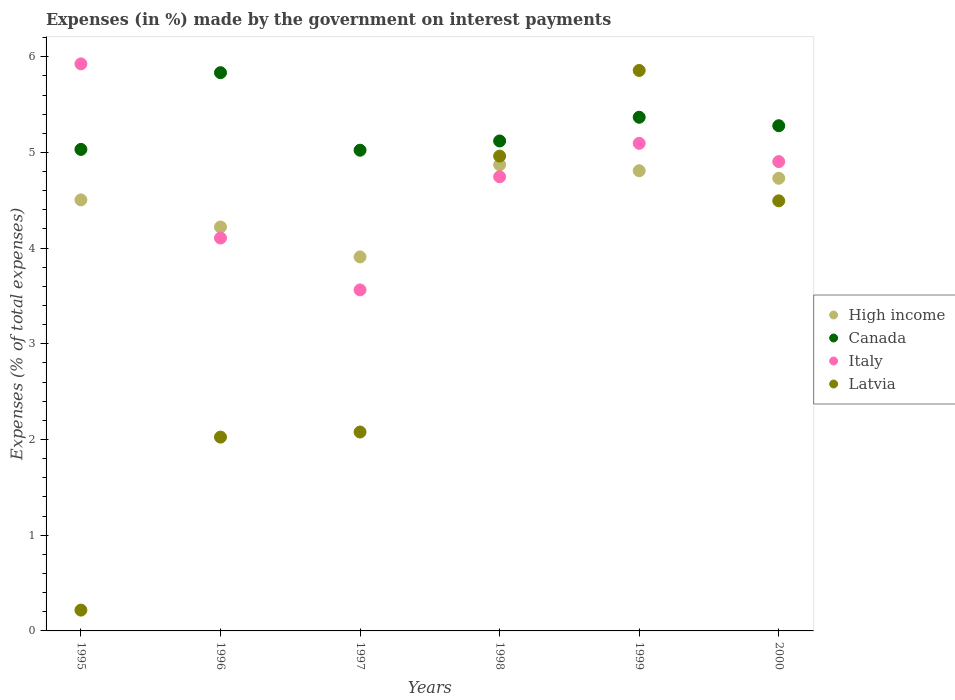What is the percentage of expenses made by the government on interest payments in Italy in 2000?
Your response must be concise. 4.9. Across all years, what is the maximum percentage of expenses made by the government on interest payments in Italy?
Your answer should be compact. 5.93. Across all years, what is the minimum percentage of expenses made by the government on interest payments in Latvia?
Give a very brief answer. 0.22. In which year was the percentage of expenses made by the government on interest payments in High income minimum?
Ensure brevity in your answer.  1997. What is the total percentage of expenses made by the government on interest payments in High income in the graph?
Offer a very short reply. 27.04. What is the difference between the percentage of expenses made by the government on interest payments in High income in 1995 and that in 1999?
Your response must be concise. -0.3. What is the difference between the percentage of expenses made by the government on interest payments in High income in 1997 and the percentage of expenses made by the government on interest payments in Canada in 1996?
Ensure brevity in your answer.  -1.93. What is the average percentage of expenses made by the government on interest payments in Latvia per year?
Offer a very short reply. 3.27. In the year 1997, what is the difference between the percentage of expenses made by the government on interest payments in Canada and percentage of expenses made by the government on interest payments in High income?
Your response must be concise. 1.12. What is the ratio of the percentage of expenses made by the government on interest payments in Italy in 1995 to that in 1996?
Make the answer very short. 1.44. Is the percentage of expenses made by the government on interest payments in Italy in 1995 less than that in 2000?
Keep it short and to the point. No. What is the difference between the highest and the second highest percentage of expenses made by the government on interest payments in High income?
Provide a succinct answer. 0.06. What is the difference between the highest and the lowest percentage of expenses made by the government on interest payments in Latvia?
Your answer should be very brief. 5.64. In how many years, is the percentage of expenses made by the government on interest payments in Latvia greater than the average percentage of expenses made by the government on interest payments in Latvia taken over all years?
Your answer should be very brief. 3. Is the sum of the percentage of expenses made by the government on interest payments in Italy in 1997 and 2000 greater than the maximum percentage of expenses made by the government on interest payments in High income across all years?
Make the answer very short. Yes. Is it the case that in every year, the sum of the percentage of expenses made by the government on interest payments in Latvia and percentage of expenses made by the government on interest payments in Italy  is greater than the percentage of expenses made by the government on interest payments in High income?
Provide a short and direct response. Yes. Is the percentage of expenses made by the government on interest payments in Latvia strictly less than the percentage of expenses made by the government on interest payments in High income over the years?
Give a very brief answer. No. How many years are there in the graph?
Offer a very short reply. 6. Are the values on the major ticks of Y-axis written in scientific E-notation?
Your answer should be very brief. No. Where does the legend appear in the graph?
Offer a very short reply. Center right. How are the legend labels stacked?
Make the answer very short. Vertical. What is the title of the graph?
Offer a very short reply. Expenses (in %) made by the government on interest payments. What is the label or title of the Y-axis?
Keep it short and to the point. Expenses (% of total expenses). What is the Expenses (% of total expenses) of High income in 1995?
Offer a terse response. 4.5. What is the Expenses (% of total expenses) in Canada in 1995?
Your answer should be compact. 5.03. What is the Expenses (% of total expenses) of Italy in 1995?
Give a very brief answer. 5.93. What is the Expenses (% of total expenses) of Latvia in 1995?
Offer a terse response. 0.22. What is the Expenses (% of total expenses) in High income in 1996?
Offer a very short reply. 4.22. What is the Expenses (% of total expenses) in Canada in 1996?
Your answer should be compact. 5.83. What is the Expenses (% of total expenses) of Italy in 1996?
Provide a succinct answer. 4.11. What is the Expenses (% of total expenses) in Latvia in 1996?
Your answer should be very brief. 2.03. What is the Expenses (% of total expenses) of High income in 1997?
Keep it short and to the point. 3.91. What is the Expenses (% of total expenses) of Canada in 1997?
Provide a short and direct response. 5.02. What is the Expenses (% of total expenses) in Italy in 1997?
Provide a short and direct response. 3.56. What is the Expenses (% of total expenses) of Latvia in 1997?
Your answer should be compact. 2.08. What is the Expenses (% of total expenses) of High income in 1998?
Your response must be concise. 4.87. What is the Expenses (% of total expenses) in Canada in 1998?
Provide a succinct answer. 5.12. What is the Expenses (% of total expenses) in Italy in 1998?
Ensure brevity in your answer.  4.75. What is the Expenses (% of total expenses) of Latvia in 1998?
Your response must be concise. 4.96. What is the Expenses (% of total expenses) of High income in 1999?
Provide a succinct answer. 4.81. What is the Expenses (% of total expenses) in Canada in 1999?
Keep it short and to the point. 5.37. What is the Expenses (% of total expenses) in Italy in 1999?
Provide a succinct answer. 5.09. What is the Expenses (% of total expenses) in Latvia in 1999?
Offer a very short reply. 5.86. What is the Expenses (% of total expenses) in High income in 2000?
Make the answer very short. 4.73. What is the Expenses (% of total expenses) of Canada in 2000?
Make the answer very short. 5.28. What is the Expenses (% of total expenses) in Italy in 2000?
Ensure brevity in your answer.  4.9. What is the Expenses (% of total expenses) of Latvia in 2000?
Your answer should be very brief. 4.49. Across all years, what is the maximum Expenses (% of total expenses) in High income?
Your answer should be compact. 4.87. Across all years, what is the maximum Expenses (% of total expenses) of Canada?
Offer a very short reply. 5.83. Across all years, what is the maximum Expenses (% of total expenses) in Italy?
Make the answer very short. 5.93. Across all years, what is the maximum Expenses (% of total expenses) in Latvia?
Provide a succinct answer. 5.86. Across all years, what is the minimum Expenses (% of total expenses) in High income?
Your response must be concise. 3.91. Across all years, what is the minimum Expenses (% of total expenses) in Canada?
Offer a terse response. 5.02. Across all years, what is the minimum Expenses (% of total expenses) in Italy?
Your response must be concise. 3.56. Across all years, what is the minimum Expenses (% of total expenses) in Latvia?
Keep it short and to the point. 0.22. What is the total Expenses (% of total expenses) in High income in the graph?
Provide a succinct answer. 27.04. What is the total Expenses (% of total expenses) of Canada in the graph?
Your answer should be compact. 31.65. What is the total Expenses (% of total expenses) in Italy in the graph?
Offer a terse response. 28.34. What is the total Expenses (% of total expenses) of Latvia in the graph?
Provide a short and direct response. 19.63. What is the difference between the Expenses (% of total expenses) of High income in 1995 and that in 1996?
Keep it short and to the point. 0.28. What is the difference between the Expenses (% of total expenses) in Canada in 1995 and that in 1996?
Ensure brevity in your answer.  -0.8. What is the difference between the Expenses (% of total expenses) in Italy in 1995 and that in 1996?
Offer a very short reply. 1.82. What is the difference between the Expenses (% of total expenses) in Latvia in 1995 and that in 1996?
Your answer should be compact. -1.81. What is the difference between the Expenses (% of total expenses) of High income in 1995 and that in 1997?
Give a very brief answer. 0.6. What is the difference between the Expenses (% of total expenses) of Canada in 1995 and that in 1997?
Give a very brief answer. 0.01. What is the difference between the Expenses (% of total expenses) in Italy in 1995 and that in 1997?
Keep it short and to the point. 2.36. What is the difference between the Expenses (% of total expenses) in Latvia in 1995 and that in 1997?
Ensure brevity in your answer.  -1.86. What is the difference between the Expenses (% of total expenses) in High income in 1995 and that in 1998?
Make the answer very short. -0.37. What is the difference between the Expenses (% of total expenses) in Canada in 1995 and that in 1998?
Ensure brevity in your answer.  -0.09. What is the difference between the Expenses (% of total expenses) of Italy in 1995 and that in 1998?
Your response must be concise. 1.18. What is the difference between the Expenses (% of total expenses) in Latvia in 1995 and that in 1998?
Provide a succinct answer. -4.74. What is the difference between the Expenses (% of total expenses) in High income in 1995 and that in 1999?
Ensure brevity in your answer.  -0.3. What is the difference between the Expenses (% of total expenses) in Canada in 1995 and that in 1999?
Your answer should be very brief. -0.34. What is the difference between the Expenses (% of total expenses) in Italy in 1995 and that in 1999?
Give a very brief answer. 0.83. What is the difference between the Expenses (% of total expenses) in Latvia in 1995 and that in 1999?
Give a very brief answer. -5.64. What is the difference between the Expenses (% of total expenses) of High income in 1995 and that in 2000?
Your answer should be very brief. -0.23. What is the difference between the Expenses (% of total expenses) in Canada in 1995 and that in 2000?
Your answer should be very brief. -0.25. What is the difference between the Expenses (% of total expenses) of Italy in 1995 and that in 2000?
Your answer should be compact. 1.02. What is the difference between the Expenses (% of total expenses) in Latvia in 1995 and that in 2000?
Ensure brevity in your answer.  -4.28. What is the difference between the Expenses (% of total expenses) of High income in 1996 and that in 1997?
Your response must be concise. 0.31. What is the difference between the Expenses (% of total expenses) of Canada in 1996 and that in 1997?
Your answer should be very brief. 0.81. What is the difference between the Expenses (% of total expenses) of Italy in 1996 and that in 1997?
Your response must be concise. 0.54. What is the difference between the Expenses (% of total expenses) in Latvia in 1996 and that in 1997?
Ensure brevity in your answer.  -0.05. What is the difference between the Expenses (% of total expenses) of High income in 1996 and that in 1998?
Ensure brevity in your answer.  -0.65. What is the difference between the Expenses (% of total expenses) of Canada in 1996 and that in 1998?
Your answer should be very brief. 0.71. What is the difference between the Expenses (% of total expenses) of Italy in 1996 and that in 1998?
Offer a very short reply. -0.64. What is the difference between the Expenses (% of total expenses) in Latvia in 1996 and that in 1998?
Your answer should be very brief. -2.94. What is the difference between the Expenses (% of total expenses) in High income in 1996 and that in 1999?
Your answer should be very brief. -0.59. What is the difference between the Expenses (% of total expenses) of Canada in 1996 and that in 1999?
Provide a succinct answer. 0.47. What is the difference between the Expenses (% of total expenses) of Italy in 1996 and that in 1999?
Your answer should be very brief. -0.99. What is the difference between the Expenses (% of total expenses) of Latvia in 1996 and that in 1999?
Ensure brevity in your answer.  -3.83. What is the difference between the Expenses (% of total expenses) of High income in 1996 and that in 2000?
Offer a terse response. -0.51. What is the difference between the Expenses (% of total expenses) in Canada in 1996 and that in 2000?
Your response must be concise. 0.55. What is the difference between the Expenses (% of total expenses) in Italy in 1996 and that in 2000?
Make the answer very short. -0.8. What is the difference between the Expenses (% of total expenses) of Latvia in 1996 and that in 2000?
Ensure brevity in your answer.  -2.47. What is the difference between the Expenses (% of total expenses) of High income in 1997 and that in 1998?
Provide a short and direct response. -0.96. What is the difference between the Expenses (% of total expenses) of Canada in 1997 and that in 1998?
Offer a terse response. -0.1. What is the difference between the Expenses (% of total expenses) in Italy in 1997 and that in 1998?
Give a very brief answer. -1.18. What is the difference between the Expenses (% of total expenses) in Latvia in 1997 and that in 1998?
Your answer should be compact. -2.88. What is the difference between the Expenses (% of total expenses) of High income in 1997 and that in 1999?
Your answer should be very brief. -0.9. What is the difference between the Expenses (% of total expenses) of Canada in 1997 and that in 1999?
Your answer should be compact. -0.34. What is the difference between the Expenses (% of total expenses) in Italy in 1997 and that in 1999?
Ensure brevity in your answer.  -1.53. What is the difference between the Expenses (% of total expenses) in Latvia in 1997 and that in 1999?
Ensure brevity in your answer.  -3.78. What is the difference between the Expenses (% of total expenses) of High income in 1997 and that in 2000?
Your answer should be compact. -0.82. What is the difference between the Expenses (% of total expenses) in Canada in 1997 and that in 2000?
Your response must be concise. -0.26. What is the difference between the Expenses (% of total expenses) in Italy in 1997 and that in 2000?
Offer a very short reply. -1.34. What is the difference between the Expenses (% of total expenses) of Latvia in 1997 and that in 2000?
Keep it short and to the point. -2.42. What is the difference between the Expenses (% of total expenses) of High income in 1998 and that in 1999?
Provide a succinct answer. 0.06. What is the difference between the Expenses (% of total expenses) in Canada in 1998 and that in 1999?
Provide a succinct answer. -0.25. What is the difference between the Expenses (% of total expenses) in Italy in 1998 and that in 1999?
Offer a terse response. -0.35. What is the difference between the Expenses (% of total expenses) of Latvia in 1998 and that in 1999?
Your response must be concise. -0.89. What is the difference between the Expenses (% of total expenses) in High income in 1998 and that in 2000?
Make the answer very short. 0.14. What is the difference between the Expenses (% of total expenses) in Canada in 1998 and that in 2000?
Offer a terse response. -0.16. What is the difference between the Expenses (% of total expenses) of Italy in 1998 and that in 2000?
Offer a very short reply. -0.16. What is the difference between the Expenses (% of total expenses) in Latvia in 1998 and that in 2000?
Give a very brief answer. 0.47. What is the difference between the Expenses (% of total expenses) in High income in 1999 and that in 2000?
Keep it short and to the point. 0.08. What is the difference between the Expenses (% of total expenses) in Canada in 1999 and that in 2000?
Provide a short and direct response. 0.09. What is the difference between the Expenses (% of total expenses) of Italy in 1999 and that in 2000?
Make the answer very short. 0.19. What is the difference between the Expenses (% of total expenses) of Latvia in 1999 and that in 2000?
Give a very brief answer. 1.36. What is the difference between the Expenses (% of total expenses) in High income in 1995 and the Expenses (% of total expenses) in Canada in 1996?
Keep it short and to the point. -1.33. What is the difference between the Expenses (% of total expenses) in High income in 1995 and the Expenses (% of total expenses) in Italy in 1996?
Your response must be concise. 0.4. What is the difference between the Expenses (% of total expenses) of High income in 1995 and the Expenses (% of total expenses) of Latvia in 1996?
Ensure brevity in your answer.  2.48. What is the difference between the Expenses (% of total expenses) in Canada in 1995 and the Expenses (% of total expenses) in Italy in 1996?
Your response must be concise. 0.93. What is the difference between the Expenses (% of total expenses) in Canada in 1995 and the Expenses (% of total expenses) in Latvia in 1996?
Keep it short and to the point. 3.01. What is the difference between the Expenses (% of total expenses) of Italy in 1995 and the Expenses (% of total expenses) of Latvia in 1996?
Your answer should be compact. 3.9. What is the difference between the Expenses (% of total expenses) of High income in 1995 and the Expenses (% of total expenses) of Canada in 1997?
Keep it short and to the point. -0.52. What is the difference between the Expenses (% of total expenses) of High income in 1995 and the Expenses (% of total expenses) of Italy in 1997?
Make the answer very short. 0.94. What is the difference between the Expenses (% of total expenses) in High income in 1995 and the Expenses (% of total expenses) in Latvia in 1997?
Provide a short and direct response. 2.43. What is the difference between the Expenses (% of total expenses) of Canada in 1995 and the Expenses (% of total expenses) of Italy in 1997?
Offer a terse response. 1.47. What is the difference between the Expenses (% of total expenses) in Canada in 1995 and the Expenses (% of total expenses) in Latvia in 1997?
Your answer should be compact. 2.95. What is the difference between the Expenses (% of total expenses) of Italy in 1995 and the Expenses (% of total expenses) of Latvia in 1997?
Offer a terse response. 3.85. What is the difference between the Expenses (% of total expenses) in High income in 1995 and the Expenses (% of total expenses) in Canada in 1998?
Offer a terse response. -0.62. What is the difference between the Expenses (% of total expenses) in High income in 1995 and the Expenses (% of total expenses) in Italy in 1998?
Keep it short and to the point. -0.24. What is the difference between the Expenses (% of total expenses) in High income in 1995 and the Expenses (% of total expenses) in Latvia in 1998?
Ensure brevity in your answer.  -0.46. What is the difference between the Expenses (% of total expenses) in Canada in 1995 and the Expenses (% of total expenses) in Italy in 1998?
Make the answer very short. 0.29. What is the difference between the Expenses (% of total expenses) in Canada in 1995 and the Expenses (% of total expenses) in Latvia in 1998?
Your answer should be very brief. 0.07. What is the difference between the Expenses (% of total expenses) in Italy in 1995 and the Expenses (% of total expenses) in Latvia in 1998?
Give a very brief answer. 0.96. What is the difference between the Expenses (% of total expenses) of High income in 1995 and the Expenses (% of total expenses) of Canada in 1999?
Keep it short and to the point. -0.86. What is the difference between the Expenses (% of total expenses) of High income in 1995 and the Expenses (% of total expenses) of Italy in 1999?
Keep it short and to the point. -0.59. What is the difference between the Expenses (% of total expenses) in High income in 1995 and the Expenses (% of total expenses) in Latvia in 1999?
Provide a succinct answer. -1.35. What is the difference between the Expenses (% of total expenses) in Canada in 1995 and the Expenses (% of total expenses) in Italy in 1999?
Make the answer very short. -0.06. What is the difference between the Expenses (% of total expenses) in Canada in 1995 and the Expenses (% of total expenses) in Latvia in 1999?
Your response must be concise. -0.82. What is the difference between the Expenses (% of total expenses) in Italy in 1995 and the Expenses (% of total expenses) in Latvia in 1999?
Ensure brevity in your answer.  0.07. What is the difference between the Expenses (% of total expenses) in High income in 1995 and the Expenses (% of total expenses) in Canada in 2000?
Keep it short and to the point. -0.77. What is the difference between the Expenses (% of total expenses) of High income in 1995 and the Expenses (% of total expenses) of Italy in 2000?
Your response must be concise. -0.4. What is the difference between the Expenses (% of total expenses) in High income in 1995 and the Expenses (% of total expenses) in Latvia in 2000?
Your answer should be compact. 0.01. What is the difference between the Expenses (% of total expenses) of Canada in 1995 and the Expenses (% of total expenses) of Italy in 2000?
Provide a succinct answer. 0.13. What is the difference between the Expenses (% of total expenses) of Canada in 1995 and the Expenses (% of total expenses) of Latvia in 2000?
Keep it short and to the point. 0.54. What is the difference between the Expenses (% of total expenses) of Italy in 1995 and the Expenses (% of total expenses) of Latvia in 2000?
Give a very brief answer. 1.43. What is the difference between the Expenses (% of total expenses) of High income in 1996 and the Expenses (% of total expenses) of Canada in 1997?
Your response must be concise. -0.8. What is the difference between the Expenses (% of total expenses) of High income in 1996 and the Expenses (% of total expenses) of Italy in 1997?
Provide a succinct answer. 0.66. What is the difference between the Expenses (% of total expenses) in High income in 1996 and the Expenses (% of total expenses) in Latvia in 1997?
Keep it short and to the point. 2.14. What is the difference between the Expenses (% of total expenses) in Canada in 1996 and the Expenses (% of total expenses) in Italy in 1997?
Ensure brevity in your answer.  2.27. What is the difference between the Expenses (% of total expenses) of Canada in 1996 and the Expenses (% of total expenses) of Latvia in 1997?
Provide a succinct answer. 3.75. What is the difference between the Expenses (% of total expenses) of Italy in 1996 and the Expenses (% of total expenses) of Latvia in 1997?
Ensure brevity in your answer.  2.03. What is the difference between the Expenses (% of total expenses) in High income in 1996 and the Expenses (% of total expenses) in Canada in 1998?
Ensure brevity in your answer.  -0.9. What is the difference between the Expenses (% of total expenses) of High income in 1996 and the Expenses (% of total expenses) of Italy in 1998?
Keep it short and to the point. -0.53. What is the difference between the Expenses (% of total expenses) of High income in 1996 and the Expenses (% of total expenses) of Latvia in 1998?
Provide a succinct answer. -0.74. What is the difference between the Expenses (% of total expenses) of Canada in 1996 and the Expenses (% of total expenses) of Italy in 1998?
Provide a short and direct response. 1.09. What is the difference between the Expenses (% of total expenses) in Canada in 1996 and the Expenses (% of total expenses) in Latvia in 1998?
Your answer should be very brief. 0.87. What is the difference between the Expenses (% of total expenses) of Italy in 1996 and the Expenses (% of total expenses) of Latvia in 1998?
Provide a short and direct response. -0.86. What is the difference between the Expenses (% of total expenses) in High income in 1996 and the Expenses (% of total expenses) in Canada in 1999?
Ensure brevity in your answer.  -1.15. What is the difference between the Expenses (% of total expenses) in High income in 1996 and the Expenses (% of total expenses) in Italy in 1999?
Your response must be concise. -0.87. What is the difference between the Expenses (% of total expenses) in High income in 1996 and the Expenses (% of total expenses) in Latvia in 1999?
Make the answer very short. -1.64. What is the difference between the Expenses (% of total expenses) in Canada in 1996 and the Expenses (% of total expenses) in Italy in 1999?
Provide a succinct answer. 0.74. What is the difference between the Expenses (% of total expenses) of Canada in 1996 and the Expenses (% of total expenses) of Latvia in 1999?
Your answer should be compact. -0.02. What is the difference between the Expenses (% of total expenses) in Italy in 1996 and the Expenses (% of total expenses) in Latvia in 1999?
Provide a succinct answer. -1.75. What is the difference between the Expenses (% of total expenses) in High income in 1996 and the Expenses (% of total expenses) in Canada in 2000?
Offer a very short reply. -1.06. What is the difference between the Expenses (% of total expenses) in High income in 1996 and the Expenses (% of total expenses) in Italy in 2000?
Keep it short and to the point. -0.68. What is the difference between the Expenses (% of total expenses) in High income in 1996 and the Expenses (% of total expenses) in Latvia in 2000?
Offer a very short reply. -0.27. What is the difference between the Expenses (% of total expenses) of Canada in 1996 and the Expenses (% of total expenses) of Italy in 2000?
Offer a very short reply. 0.93. What is the difference between the Expenses (% of total expenses) in Canada in 1996 and the Expenses (% of total expenses) in Latvia in 2000?
Ensure brevity in your answer.  1.34. What is the difference between the Expenses (% of total expenses) of Italy in 1996 and the Expenses (% of total expenses) of Latvia in 2000?
Provide a succinct answer. -0.39. What is the difference between the Expenses (% of total expenses) in High income in 1997 and the Expenses (% of total expenses) in Canada in 1998?
Make the answer very short. -1.21. What is the difference between the Expenses (% of total expenses) in High income in 1997 and the Expenses (% of total expenses) in Italy in 1998?
Your response must be concise. -0.84. What is the difference between the Expenses (% of total expenses) in High income in 1997 and the Expenses (% of total expenses) in Latvia in 1998?
Your response must be concise. -1.05. What is the difference between the Expenses (% of total expenses) in Canada in 1997 and the Expenses (% of total expenses) in Italy in 1998?
Offer a very short reply. 0.28. What is the difference between the Expenses (% of total expenses) in Canada in 1997 and the Expenses (% of total expenses) in Latvia in 1998?
Your answer should be compact. 0.06. What is the difference between the Expenses (% of total expenses) in Italy in 1997 and the Expenses (% of total expenses) in Latvia in 1998?
Provide a short and direct response. -1.4. What is the difference between the Expenses (% of total expenses) in High income in 1997 and the Expenses (% of total expenses) in Canada in 1999?
Your response must be concise. -1.46. What is the difference between the Expenses (% of total expenses) of High income in 1997 and the Expenses (% of total expenses) of Italy in 1999?
Your answer should be very brief. -1.19. What is the difference between the Expenses (% of total expenses) in High income in 1997 and the Expenses (% of total expenses) in Latvia in 1999?
Your answer should be very brief. -1.95. What is the difference between the Expenses (% of total expenses) in Canada in 1997 and the Expenses (% of total expenses) in Italy in 1999?
Provide a succinct answer. -0.07. What is the difference between the Expenses (% of total expenses) of Canada in 1997 and the Expenses (% of total expenses) of Latvia in 1999?
Give a very brief answer. -0.83. What is the difference between the Expenses (% of total expenses) of Italy in 1997 and the Expenses (% of total expenses) of Latvia in 1999?
Give a very brief answer. -2.29. What is the difference between the Expenses (% of total expenses) in High income in 1997 and the Expenses (% of total expenses) in Canada in 2000?
Your response must be concise. -1.37. What is the difference between the Expenses (% of total expenses) of High income in 1997 and the Expenses (% of total expenses) of Italy in 2000?
Ensure brevity in your answer.  -1. What is the difference between the Expenses (% of total expenses) of High income in 1997 and the Expenses (% of total expenses) of Latvia in 2000?
Ensure brevity in your answer.  -0.59. What is the difference between the Expenses (% of total expenses) of Canada in 1997 and the Expenses (% of total expenses) of Italy in 2000?
Keep it short and to the point. 0.12. What is the difference between the Expenses (% of total expenses) in Canada in 1997 and the Expenses (% of total expenses) in Latvia in 2000?
Your response must be concise. 0.53. What is the difference between the Expenses (% of total expenses) of Italy in 1997 and the Expenses (% of total expenses) of Latvia in 2000?
Your answer should be very brief. -0.93. What is the difference between the Expenses (% of total expenses) in High income in 1998 and the Expenses (% of total expenses) in Canada in 1999?
Make the answer very short. -0.5. What is the difference between the Expenses (% of total expenses) in High income in 1998 and the Expenses (% of total expenses) in Italy in 1999?
Keep it short and to the point. -0.22. What is the difference between the Expenses (% of total expenses) of High income in 1998 and the Expenses (% of total expenses) of Latvia in 1999?
Provide a succinct answer. -0.98. What is the difference between the Expenses (% of total expenses) of Canada in 1998 and the Expenses (% of total expenses) of Italy in 1999?
Provide a short and direct response. 0.02. What is the difference between the Expenses (% of total expenses) in Canada in 1998 and the Expenses (% of total expenses) in Latvia in 1999?
Make the answer very short. -0.74. What is the difference between the Expenses (% of total expenses) of Italy in 1998 and the Expenses (% of total expenses) of Latvia in 1999?
Keep it short and to the point. -1.11. What is the difference between the Expenses (% of total expenses) in High income in 1998 and the Expenses (% of total expenses) in Canada in 2000?
Keep it short and to the point. -0.41. What is the difference between the Expenses (% of total expenses) of High income in 1998 and the Expenses (% of total expenses) of Italy in 2000?
Make the answer very short. -0.03. What is the difference between the Expenses (% of total expenses) in High income in 1998 and the Expenses (% of total expenses) in Latvia in 2000?
Your response must be concise. 0.38. What is the difference between the Expenses (% of total expenses) of Canada in 1998 and the Expenses (% of total expenses) of Italy in 2000?
Keep it short and to the point. 0.22. What is the difference between the Expenses (% of total expenses) in Canada in 1998 and the Expenses (% of total expenses) in Latvia in 2000?
Your answer should be very brief. 0.63. What is the difference between the Expenses (% of total expenses) in Italy in 1998 and the Expenses (% of total expenses) in Latvia in 2000?
Keep it short and to the point. 0.25. What is the difference between the Expenses (% of total expenses) in High income in 1999 and the Expenses (% of total expenses) in Canada in 2000?
Make the answer very short. -0.47. What is the difference between the Expenses (% of total expenses) of High income in 1999 and the Expenses (% of total expenses) of Italy in 2000?
Your response must be concise. -0.1. What is the difference between the Expenses (% of total expenses) of High income in 1999 and the Expenses (% of total expenses) of Latvia in 2000?
Your answer should be compact. 0.31. What is the difference between the Expenses (% of total expenses) in Canada in 1999 and the Expenses (% of total expenses) in Italy in 2000?
Your answer should be compact. 0.46. What is the difference between the Expenses (% of total expenses) of Canada in 1999 and the Expenses (% of total expenses) of Latvia in 2000?
Your response must be concise. 0.87. What is the difference between the Expenses (% of total expenses) of Italy in 1999 and the Expenses (% of total expenses) of Latvia in 2000?
Give a very brief answer. 0.6. What is the average Expenses (% of total expenses) in High income per year?
Ensure brevity in your answer.  4.51. What is the average Expenses (% of total expenses) of Canada per year?
Keep it short and to the point. 5.28. What is the average Expenses (% of total expenses) in Italy per year?
Provide a succinct answer. 4.72. What is the average Expenses (% of total expenses) in Latvia per year?
Provide a succinct answer. 3.27. In the year 1995, what is the difference between the Expenses (% of total expenses) of High income and Expenses (% of total expenses) of Canada?
Your answer should be very brief. -0.53. In the year 1995, what is the difference between the Expenses (% of total expenses) of High income and Expenses (% of total expenses) of Italy?
Offer a very short reply. -1.42. In the year 1995, what is the difference between the Expenses (% of total expenses) of High income and Expenses (% of total expenses) of Latvia?
Offer a very short reply. 4.29. In the year 1995, what is the difference between the Expenses (% of total expenses) of Canada and Expenses (% of total expenses) of Italy?
Provide a short and direct response. -0.89. In the year 1995, what is the difference between the Expenses (% of total expenses) of Canada and Expenses (% of total expenses) of Latvia?
Provide a short and direct response. 4.81. In the year 1995, what is the difference between the Expenses (% of total expenses) in Italy and Expenses (% of total expenses) in Latvia?
Your response must be concise. 5.71. In the year 1996, what is the difference between the Expenses (% of total expenses) of High income and Expenses (% of total expenses) of Canada?
Make the answer very short. -1.61. In the year 1996, what is the difference between the Expenses (% of total expenses) of High income and Expenses (% of total expenses) of Italy?
Ensure brevity in your answer.  0.12. In the year 1996, what is the difference between the Expenses (% of total expenses) in High income and Expenses (% of total expenses) in Latvia?
Your answer should be very brief. 2.2. In the year 1996, what is the difference between the Expenses (% of total expenses) of Canada and Expenses (% of total expenses) of Italy?
Keep it short and to the point. 1.73. In the year 1996, what is the difference between the Expenses (% of total expenses) in Canada and Expenses (% of total expenses) in Latvia?
Your answer should be compact. 3.81. In the year 1996, what is the difference between the Expenses (% of total expenses) in Italy and Expenses (% of total expenses) in Latvia?
Make the answer very short. 2.08. In the year 1997, what is the difference between the Expenses (% of total expenses) in High income and Expenses (% of total expenses) in Canada?
Your answer should be compact. -1.12. In the year 1997, what is the difference between the Expenses (% of total expenses) of High income and Expenses (% of total expenses) of Italy?
Offer a very short reply. 0.34. In the year 1997, what is the difference between the Expenses (% of total expenses) in High income and Expenses (% of total expenses) in Latvia?
Keep it short and to the point. 1.83. In the year 1997, what is the difference between the Expenses (% of total expenses) of Canada and Expenses (% of total expenses) of Italy?
Ensure brevity in your answer.  1.46. In the year 1997, what is the difference between the Expenses (% of total expenses) in Canada and Expenses (% of total expenses) in Latvia?
Provide a succinct answer. 2.94. In the year 1997, what is the difference between the Expenses (% of total expenses) of Italy and Expenses (% of total expenses) of Latvia?
Your answer should be compact. 1.49. In the year 1998, what is the difference between the Expenses (% of total expenses) in High income and Expenses (% of total expenses) in Canada?
Make the answer very short. -0.25. In the year 1998, what is the difference between the Expenses (% of total expenses) of High income and Expenses (% of total expenses) of Italy?
Offer a very short reply. 0.13. In the year 1998, what is the difference between the Expenses (% of total expenses) of High income and Expenses (% of total expenses) of Latvia?
Make the answer very short. -0.09. In the year 1998, what is the difference between the Expenses (% of total expenses) in Canada and Expenses (% of total expenses) in Italy?
Your answer should be compact. 0.37. In the year 1998, what is the difference between the Expenses (% of total expenses) of Canada and Expenses (% of total expenses) of Latvia?
Give a very brief answer. 0.16. In the year 1998, what is the difference between the Expenses (% of total expenses) of Italy and Expenses (% of total expenses) of Latvia?
Keep it short and to the point. -0.22. In the year 1999, what is the difference between the Expenses (% of total expenses) of High income and Expenses (% of total expenses) of Canada?
Your response must be concise. -0.56. In the year 1999, what is the difference between the Expenses (% of total expenses) in High income and Expenses (% of total expenses) in Italy?
Keep it short and to the point. -0.29. In the year 1999, what is the difference between the Expenses (% of total expenses) in High income and Expenses (% of total expenses) in Latvia?
Give a very brief answer. -1.05. In the year 1999, what is the difference between the Expenses (% of total expenses) in Canada and Expenses (% of total expenses) in Italy?
Your response must be concise. 0.27. In the year 1999, what is the difference between the Expenses (% of total expenses) of Canada and Expenses (% of total expenses) of Latvia?
Provide a short and direct response. -0.49. In the year 1999, what is the difference between the Expenses (% of total expenses) of Italy and Expenses (% of total expenses) of Latvia?
Offer a terse response. -0.76. In the year 2000, what is the difference between the Expenses (% of total expenses) of High income and Expenses (% of total expenses) of Canada?
Keep it short and to the point. -0.55. In the year 2000, what is the difference between the Expenses (% of total expenses) of High income and Expenses (% of total expenses) of Italy?
Keep it short and to the point. -0.17. In the year 2000, what is the difference between the Expenses (% of total expenses) in High income and Expenses (% of total expenses) in Latvia?
Your answer should be compact. 0.24. In the year 2000, what is the difference between the Expenses (% of total expenses) in Canada and Expenses (% of total expenses) in Italy?
Your answer should be compact. 0.37. In the year 2000, what is the difference between the Expenses (% of total expenses) of Canada and Expenses (% of total expenses) of Latvia?
Offer a very short reply. 0.78. In the year 2000, what is the difference between the Expenses (% of total expenses) in Italy and Expenses (% of total expenses) in Latvia?
Ensure brevity in your answer.  0.41. What is the ratio of the Expenses (% of total expenses) of High income in 1995 to that in 1996?
Make the answer very short. 1.07. What is the ratio of the Expenses (% of total expenses) of Canada in 1995 to that in 1996?
Your answer should be very brief. 0.86. What is the ratio of the Expenses (% of total expenses) of Italy in 1995 to that in 1996?
Ensure brevity in your answer.  1.44. What is the ratio of the Expenses (% of total expenses) of Latvia in 1995 to that in 1996?
Offer a terse response. 0.11. What is the ratio of the Expenses (% of total expenses) in High income in 1995 to that in 1997?
Ensure brevity in your answer.  1.15. What is the ratio of the Expenses (% of total expenses) of Italy in 1995 to that in 1997?
Your response must be concise. 1.66. What is the ratio of the Expenses (% of total expenses) in Latvia in 1995 to that in 1997?
Give a very brief answer. 0.1. What is the ratio of the Expenses (% of total expenses) of High income in 1995 to that in 1998?
Your answer should be compact. 0.92. What is the ratio of the Expenses (% of total expenses) in Canada in 1995 to that in 1998?
Your response must be concise. 0.98. What is the ratio of the Expenses (% of total expenses) in Italy in 1995 to that in 1998?
Your answer should be compact. 1.25. What is the ratio of the Expenses (% of total expenses) in Latvia in 1995 to that in 1998?
Your answer should be compact. 0.04. What is the ratio of the Expenses (% of total expenses) of High income in 1995 to that in 1999?
Your answer should be compact. 0.94. What is the ratio of the Expenses (% of total expenses) in Canada in 1995 to that in 1999?
Your answer should be very brief. 0.94. What is the ratio of the Expenses (% of total expenses) in Italy in 1995 to that in 1999?
Ensure brevity in your answer.  1.16. What is the ratio of the Expenses (% of total expenses) of Latvia in 1995 to that in 1999?
Provide a short and direct response. 0.04. What is the ratio of the Expenses (% of total expenses) in High income in 1995 to that in 2000?
Provide a succinct answer. 0.95. What is the ratio of the Expenses (% of total expenses) of Canada in 1995 to that in 2000?
Your answer should be compact. 0.95. What is the ratio of the Expenses (% of total expenses) in Italy in 1995 to that in 2000?
Provide a short and direct response. 1.21. What is the ratio of the Expenses (% of total expenses) in Latvia in 1995 to that in 2000?
Provide a succinct answer. 0.05. What is the ratio of the Expenses (% of total expenses) of High income in 1996 to that in 1997?
Give a very brief answer. 1.08. What is the ratio of the Expenses (% of total expenses) of Canada in 1996 to that in 1997?
Keep it short and to the point. 1.16. What is the ratio of the Expenses (% of total expenses) of Italy in 1996 to that in 1997?
Offer a very short reply. 1.15. What is the ratio of the Expenses (% of total expenses) of Latvia in 1996 to that in 1997?
Give a very brief answer. 0.97. What is the ratio of the Expenses (% of total expenses) of High income in 1996 to that in 1998?
Provide a short and direct response. 0.87. What is the ratio of the Expenses (% of total expenses) in Canada in 1996 to that in 1998?
Keep it short and to the point. 1.14. What is the ratio of the Expenses (% of total expenses) in Italy in 1996 to that in 1998?
Your answer should be very brief. 0.87. What is the ratio of the Expenses (% of total expenses) of Latvia in 1996 to that in 1998?
Your answer should be compact. 0.41. What is the ratio of the Expenses (% of total expenses) in High income in 1996 to that in 1999?
Give a very brief answer. 0.88. What is the ratio of the Expenses (% of total expenses) in Canada in 1996 to that in 1999?
Provide a succinct answer. 1.09. What is the ratio of the Expenses (% of total expenses) of Italy in 1996 to that in 1999?
Offer a very short reply. 0.81. What is the ratio of the Expenses (% of total expenses) of Latvia in 1996 to that in 1999?
Give a very brief answer. 0.35. What is the ratio of the Expenses (% of total expenses) in High income in 1996 to that in 2000?
Make the answer very short. 0.89. What is the ratio of the Expenses (% of total expenses) in Canada in 1996 to that in 2000?
Give a very brief answer. 1.1. What is the ratio of the Expenses (% of total expenses) in Italy in 1996 to that in 2000?
Keep it short and to the point. 0.84. What is the ratio of the Expenses (% of total expenses) in Latvia in 1996 to that in 2000?
Make the answer very short. 0.45. What is the ratio of the Expenses (% of total expenses) in High income in 1997 to that in 1998?
Offer a very short reply. 0.8. What is the ratio of the Expenses (% of total expenses) in Canada in 1997 to that in 1998?
Offer a very short reply. 0.98. What is the ratio of the Expenses (% of total expenses) in Italy in 1997 to that in 1998?
Your answer should be very brief. 0.75. What is the ratio of the Expenses (% of total expenses) in Latvia in 1997 to that in 1998?
Offer a terse response. 0.42. What is the ratio of the Expenses (% of total expenses) in High income in 1997 to that in 1999?
Keep it short and to the point. 0.81. What is the ratio of the Expenses (% of total expenses) of Canada in 1997 to that in 1999?
Give a very brief answer. 0.94. What is the ratio of the Expenses (% of total expenses) in Italy in 1997 to that in 1999?
Ensure brevity in your answer.  0.7. What is the ratio of the Expenses (% of total expenses) of Latvia in 1997 to that in 1999?
Keep it short and to the point. 0.35. What is the ratio of the Expenses (% of total expenses) of High income in 1997 to that in 2000?
Make the answer very short. 0.83. What is the ratio of the Expenses (% of total expenses) of Canada in 1997 to that in 2000?
Give a very brief answer. 0.95. What is the ratio of the Expenses (% of total expenses) of Italy in 1997 to that in 2000?
Keep it short and to the point. 0.73. What is the ratio of the Expenses (% of total expenses) of Latvia in 1997 to that in 2000?
Keep it short and to the point. 0.46. What is the ratio of the Expenses (% of total expenses) of High income in 1998 to that in 1999?
Ensure brevity in your answer.  1.01. What is the ratio of the Expenses (% of total expenses) of Canada in 1998 to that in 1999?
Your answer should be compact. 0.95. What is the ratio of the Expenses (% of total expenses) of Italy in 1998 to that in 1999?
Your response must be concise. 0.93. What is the ratio of the Expenses (% of total expenses) of Latvia in 1998 to that in 1999?
Offer a terse response. 0.85. What is the ratio of the Expenses (% of total expenses) in High income in 1998 to that in 2000?
Your answer should be very brief. 1.03. What is the ratio of the Expenses (% of total expenses) in Canada in 1998 to that in 2000?
Provide a succinct answer. 0.97. What is the ratio of the Expenses (% of total expenses) in Italy in 1998 to that in 2000?
Give a very brief answer. 0.97. What is the ratio of the Expenses (% of total expenses) in Latvia in 1998 to that in 2000?
Give a very brief answer. 1.1. What is the ratio of the Expenses (% of total expenses) in High income in 1999 to that in 2000?
Provide a succinct answer. 1.02. What is the ratio of the Expenses (% of total expenses) of Canada in 1999 to that in 2000?
Your answer should be compact. 1.02. What is the ratio of the Expenses (% of total expenses) in Italy in 1999 to that in 2000?
Keep it short and to the point. 1.04. What is the ratio of the Expenses (% of total expenses) in Latvia in 1999 to that in 2000?
Offer a very short reply. 1.3. What is the difference between the highest and the second highest Expenses (% of total expenses) in High income?
Offer a terse response. 0.06. What is the difference between the highest and the second highest Expenses (% of total expenses) of Canada?
Make the answer very short. 0.47. What is the difference between the highest and the second highest Expenses (% of total expenses) in Italy?
Keep it short and to the point. 0.83. What is the difference between the highest and the second highest Expenses (% of total expenses) of Latvia?
Your answer should be compact. 0.89. What is the difference between the highest and the lowest Expenses (% of total expenses) in High income?
Give a very brief answer. 0.96. What is the difference between the highest and the lowest Expenses (% of total expenses) of Canada?
Provide a short and direct response. 0.81. What is the difference between the highest and the lowest Expenses (% of total expenses) of Italy?
Keep it short and to the point. 2.36. What is the difference between the highest and the lowest Expenses (% of total expenses) of Latvia?
Ensure brevity in your answer.  5.64. 